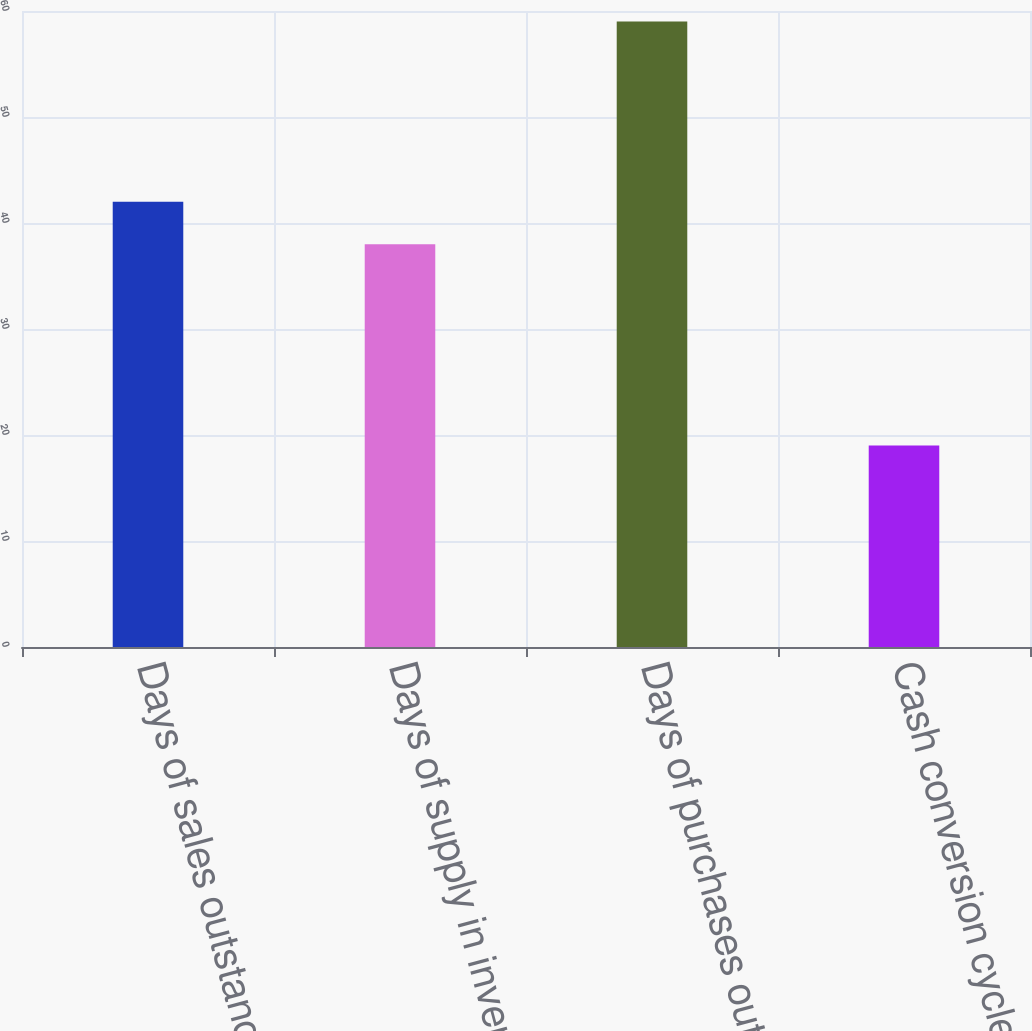Convert chart to OTSL. <chart><loc_0><loc_0><loc_500><loc_500><bar_chart><fcel>Days of sales outstanding in<fcel>Days of supply in inventory<fcel>Days of purchases outstanding<fcel>Cash conversion cycle<nl><fcel>42<fcel>38<fcel>59<fcel>19<nl></chart> 